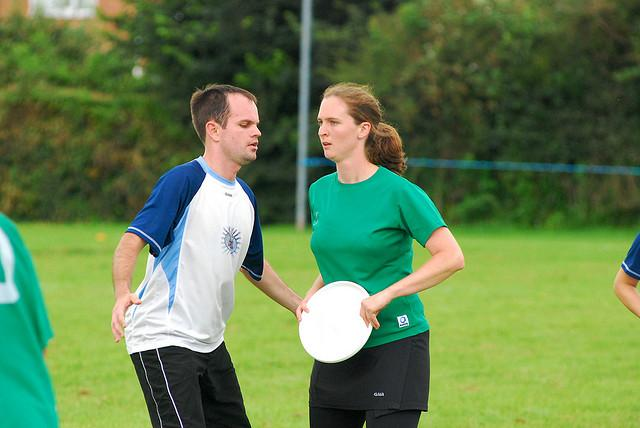The man in blue wants to do what to the frisbee holder? block 